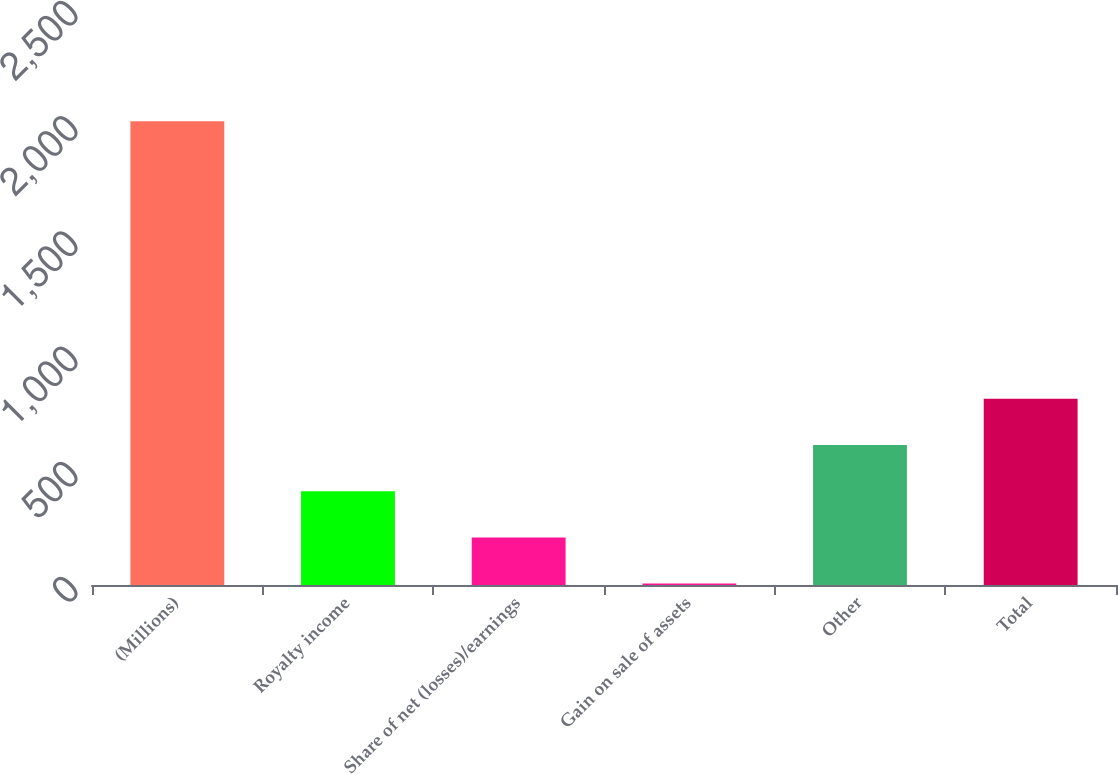Convert chart. <chart><loc_0><loc_0><loc_500><loc_500><bar_chart><fcel>(Millions)<fcel>Royalty income<fcel>Share of net (losses)/earnings<fcel>Gain on sale of assets<fcel>Other<fcel>Total<nl><fcel>2013<fcel>407.4<fcel>206.7<fcel>6<fcel>608.1<fcel>808.8<nl></chart> 